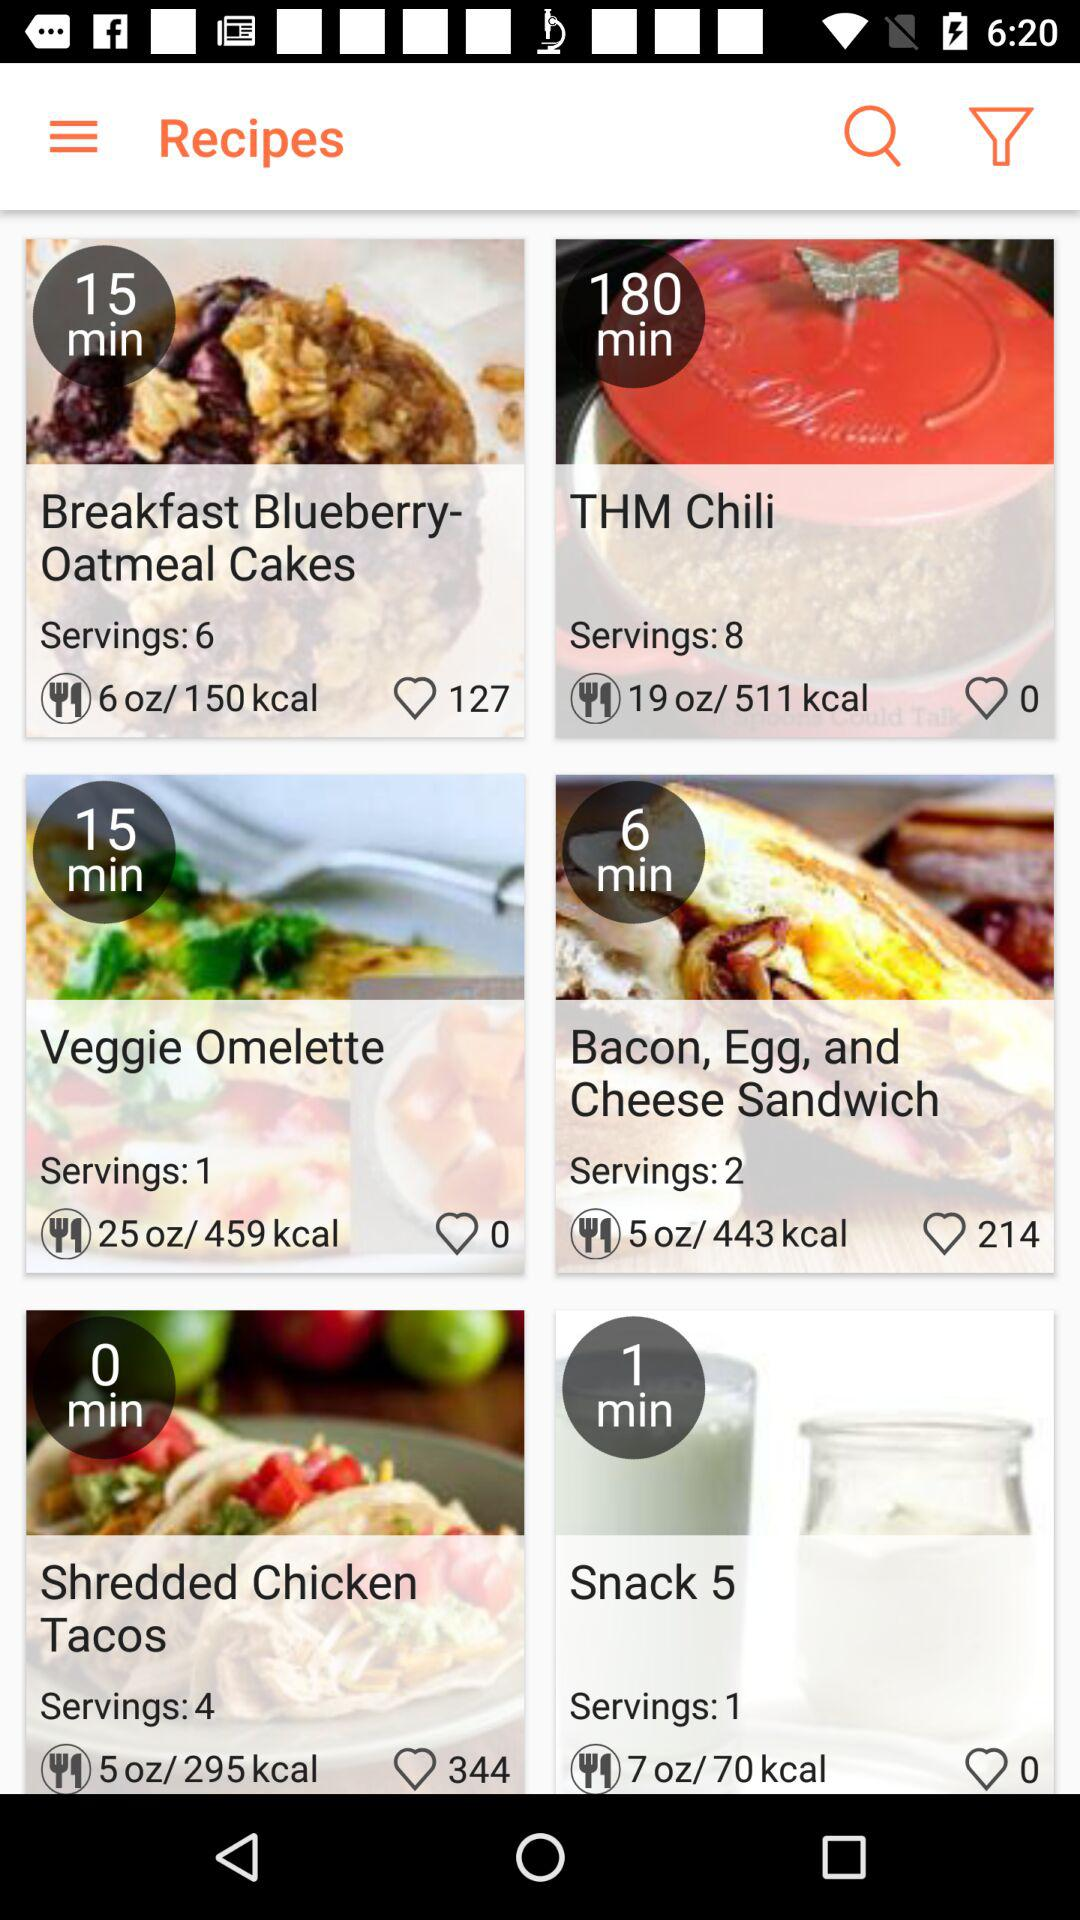How many servings of "THM Chili" can be served? The number of servings that can be served is 8. 